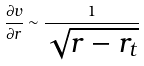Convert formula to latex. <formula><loc_0><loc_0><loc_500><loc_500>\frac { \partial v } { \partial r } \sim \frac { 1 } { \sqrt { r - r _ { t } } }</formula> 